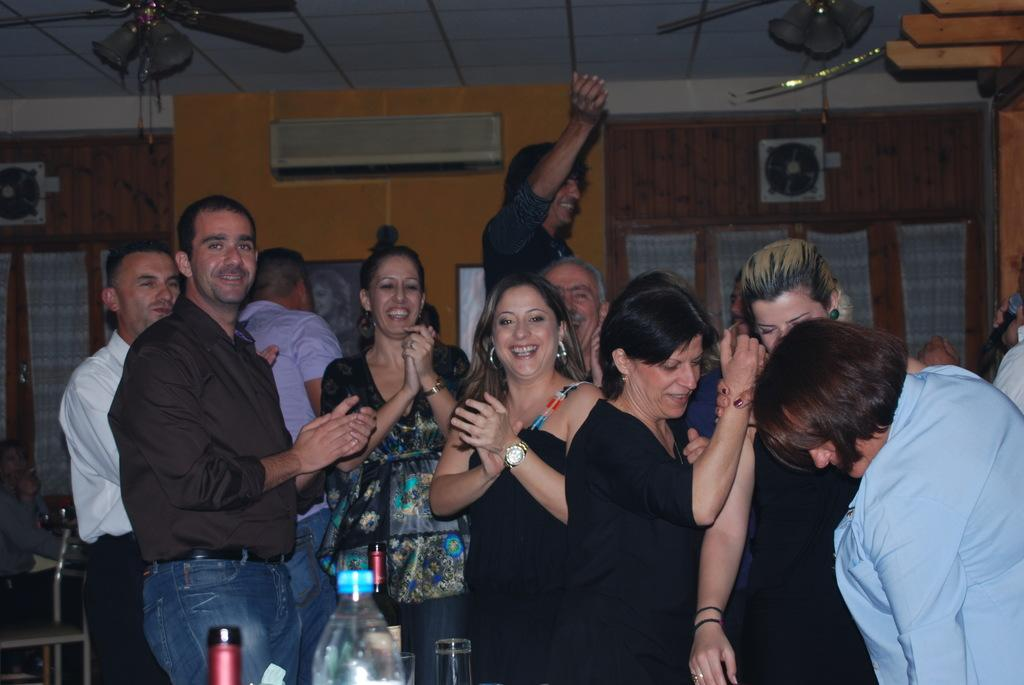What can be seen in the front of the image? There is a group of people standing in the front of the image. What objects are present in the image that might be used for cooling? There are fans and an air conditioner in the image. What architectural features can be seen in the image? There is a wall, a door, and a photo frame in the image. What items are visible in the image that might be used for drinking? There is a bottle and glasses in the image. What type of oatmeal is being served at the committee meeting in the image? There is no committee meeting or oatmeal present in the image. 